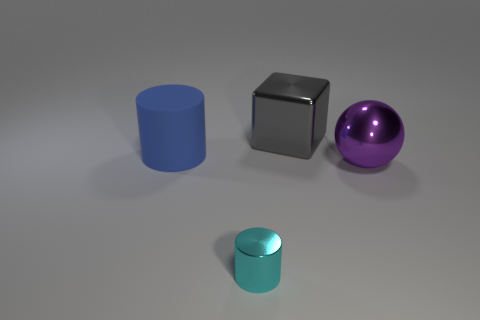Add 3 tiny cyan things. How many objects exist? 7 Subtract all balls. How many objects are left? 3 Subtract all large yellow shiny balls. Subtract all cyan cylinders. How many objects are left? 3 Add 1 small shiny objects. How many small shiny objects are left? 2 Add 4 purple metal spheres. How many purple metal spheres exist? 5 Subtract 0 brown cubes. How many objects are left? 4 